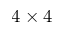Convert formula to latex. <formula><loc_0><loc_0><loc_500><loc_500>4 \times 4</formula> 